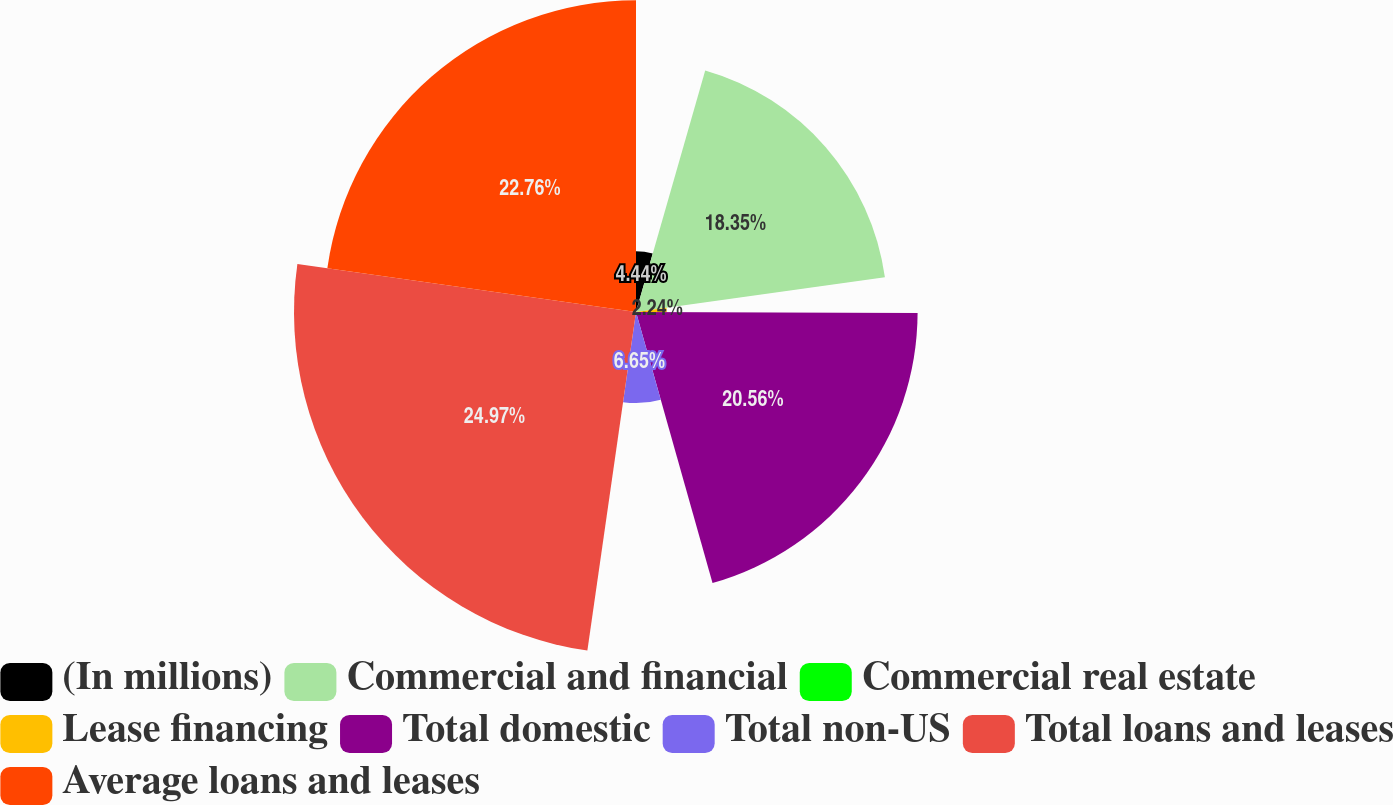Convert chart. <chart><loc_0><loc_0><loc_500><loc_500><pie_chart><fcel>(In millions)<fcel>Commercial and financial<fcel>Commercial real estate<fcel>Lease financing<fcel>Total domestic<fcel>Total non-US<fcel>Total loans and leases<fcel>Average loans and leases<nl><fcel>4.44%<fcel>18.35%<fcel>0.03%<fcel>2.24%<fcel>20.56%<fcel>6.65%<fcel>24.97%<fcel>22.76%<nl></chart> 